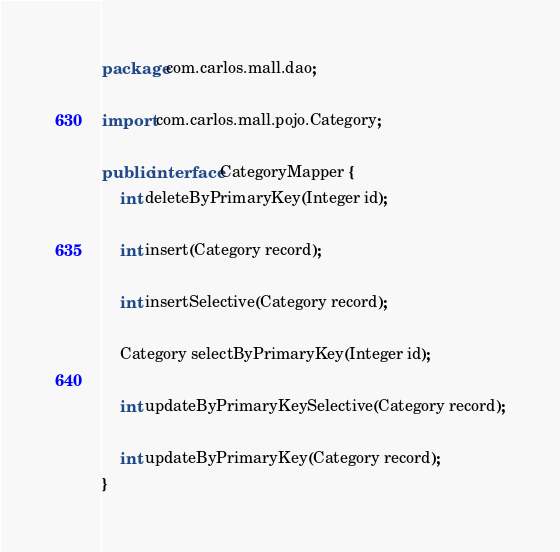Convert code to text. <code><loc_0><loc_0><loc_500><loc_500><_Java_>package com.carlos.mall.dao;

import com.carlos.mall.pojo.Category;

public interface CategoryMapper {
    int deleteByPrimaryKey(Integer id);

    int insert(Category record);

    int insertSelective(Category record);

    Category selectByPrimaryKey(Integer id);

    int updateByPrimaryKeySelective(Category record);

    int updateByPrimaryKey(Category record);
}</code> 